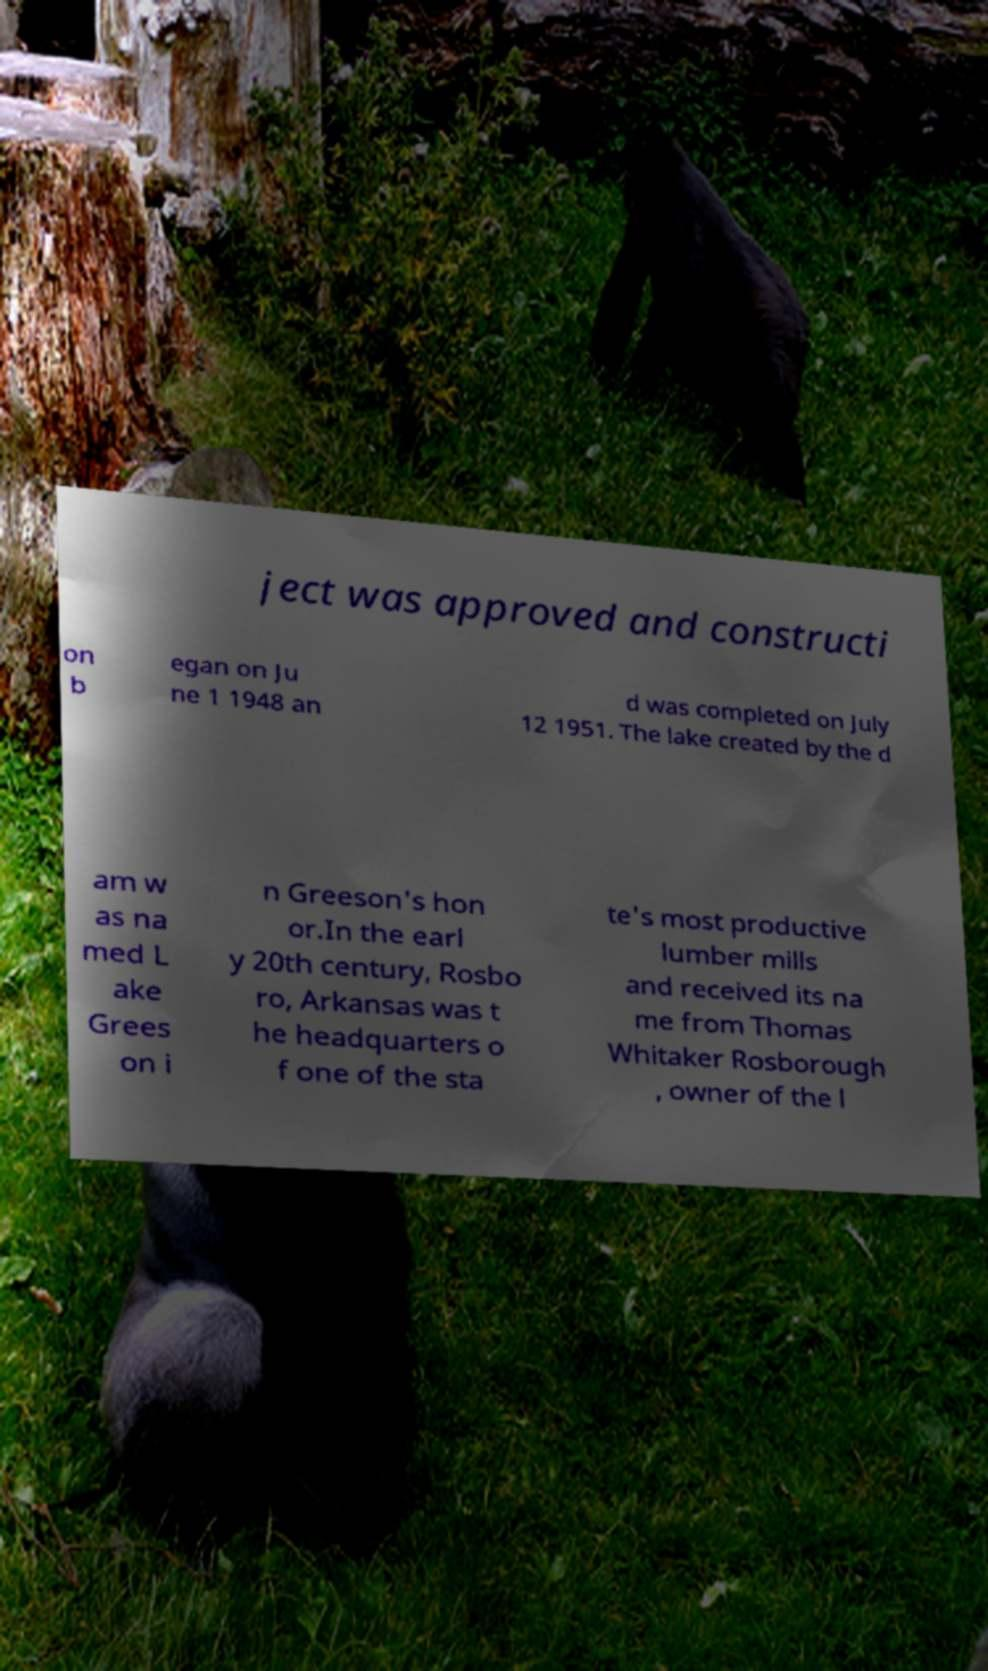What messages or text are displayed in this image? I need them in a readable, typed format. ject was approved and constructi on b egan on Ju ne 1 1948 an d was completed on July 12 1951. The lake created by the d am w as na med L ake Grees on i n Greeson's hon or.In the earl y 20th century, Rosbo ro, Arkansas was t he headquarters o f one of the sta te's most productive lumber mills and received its na me from Thomas Whitaker Rosborough , owner of the l 